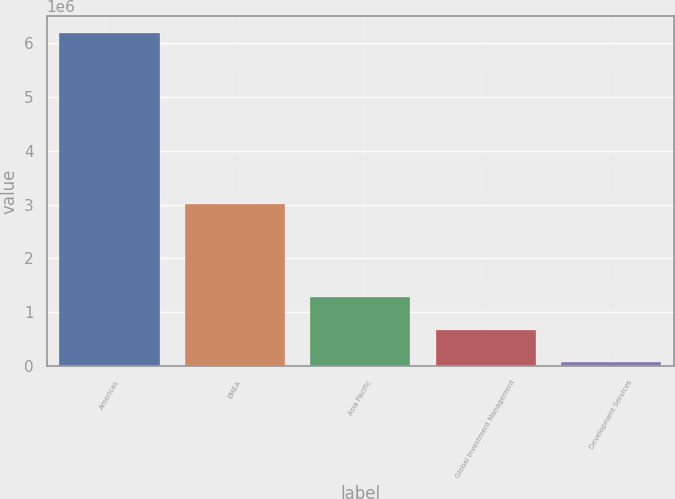<chart> <loc_0><loc_0><loc_500><loc_500><bar_chart><fcel>Americas<fcel>EMEA<fcel>Asia Pacific<fcel>Global Investment Management<fcel>Development Services<nl><fcel>6.18991e+06<fcel>3.00448e+06<fcel>1.2905e+06<fcel>678070<fcel>65643<nl></chart> 